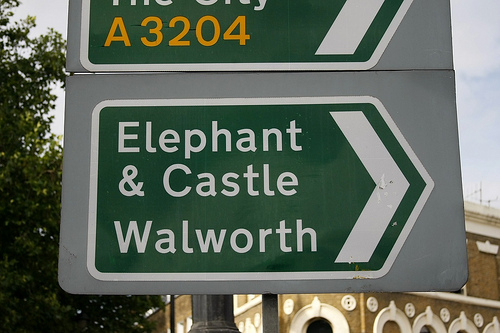Please transcribe the text information in this image. A 3204 Elephant Castle Wlworth &amp; 